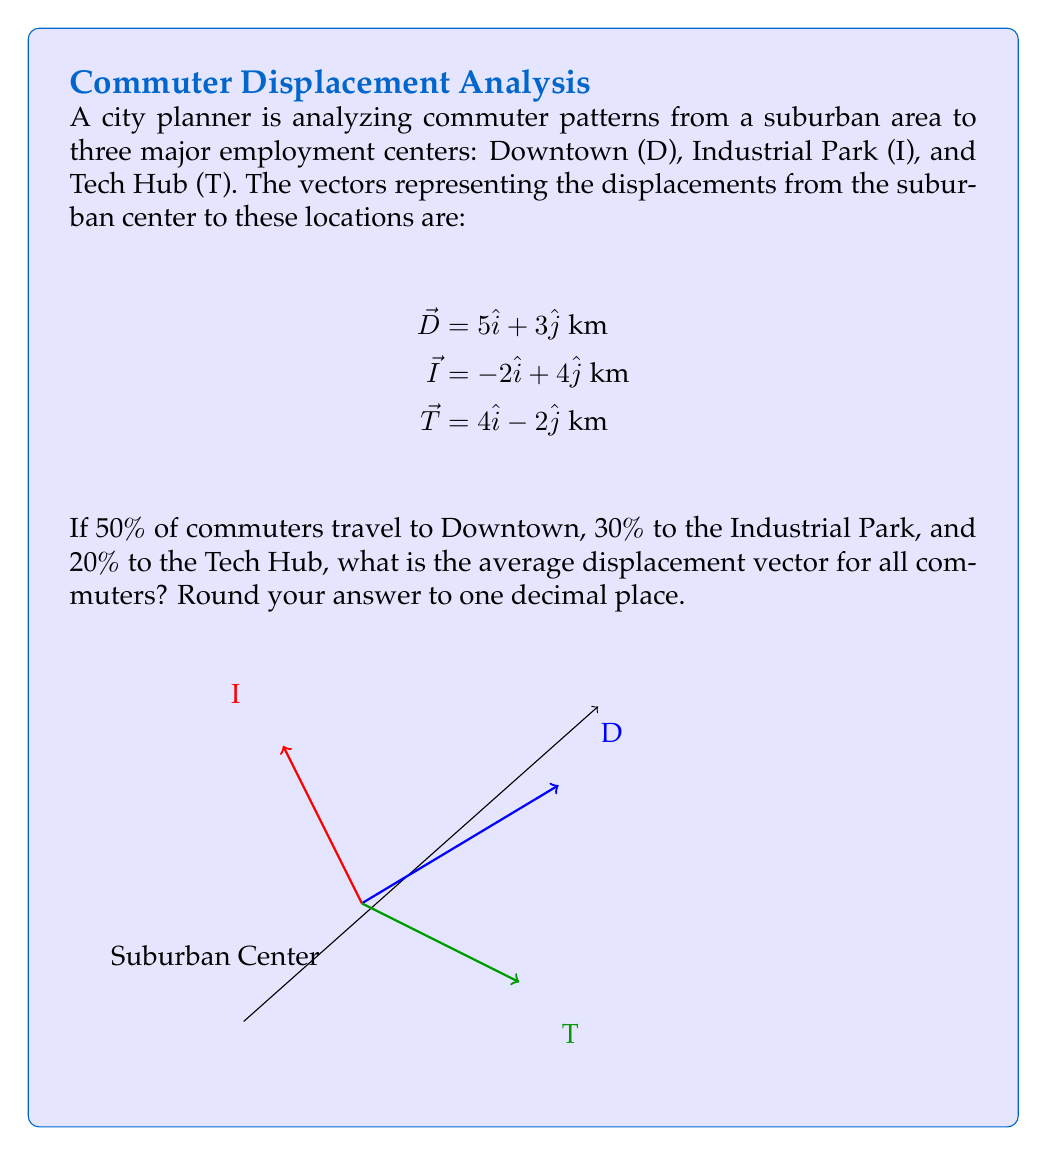Provide a solution to this math problem. To solve this problem, we'll use vector addition and scalar multiplication. Here's the step-by-step process:

1) First, we need to scale each vector by its corresponding percentage of commuters:

   Downtown: $0.50 \vec{D} = 0.50(5\hat{i} + 3\hat{j}) = 2.5\hat{i} + 1.5\hat{j}$
   Industrial Park: $0.30 \vec{I} = 0.30(-2\hat{i} + 4\hat{j}) = -0.6\hat{i} + 1.2\hat{j}$
   Tech Hub: $0.20 \vec{T} = 0.20(4\hat{i} - 2\hat{j}) = 0.8\hat{i} - 0.4\hat{j}$

2) Now, we add these scaled vectors to get the average displacement vector:

   $\vec{R} = (2.5\hat{i} + 1.5\hat{j}) + (-0.6\hat{i} + 1.2\hat{j}) + (0.8\hat{i} - 0.4\hat{j})$

3) Combining like terms:

   $\vec{R} = (2.5 - 0.6 + 0.8)\hat{i} + (1.5 + 1.2 - 0.4)\hat{j}$
   $\vec{R} = 2.7\hat{i} + 2.3\hat{j}$

4) Rounding to one decimal place:

   $\vec{R} \approx 2.7\hat{i} + 2.3\hat{j}$ km

This vector represents the average displacement of all commuters from the suburban center.
Answer: $2.7\hat{i} + 2.3\hat{j}$ km 